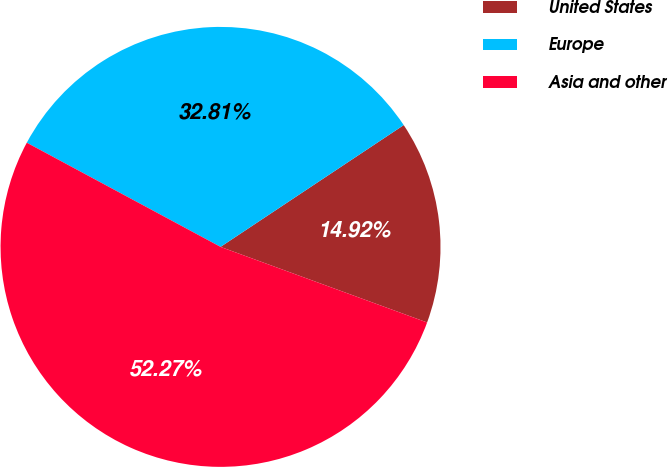Convert chart to OTSL. <chart><loc_0><loc_0><loc_500><loc_500><pie_chart><fcel>United States<fcel>Europe<fcel>Asia and other<nl><fcel>14.92%<fcel>32.81%<fcel>52.27%<nl></chart> 